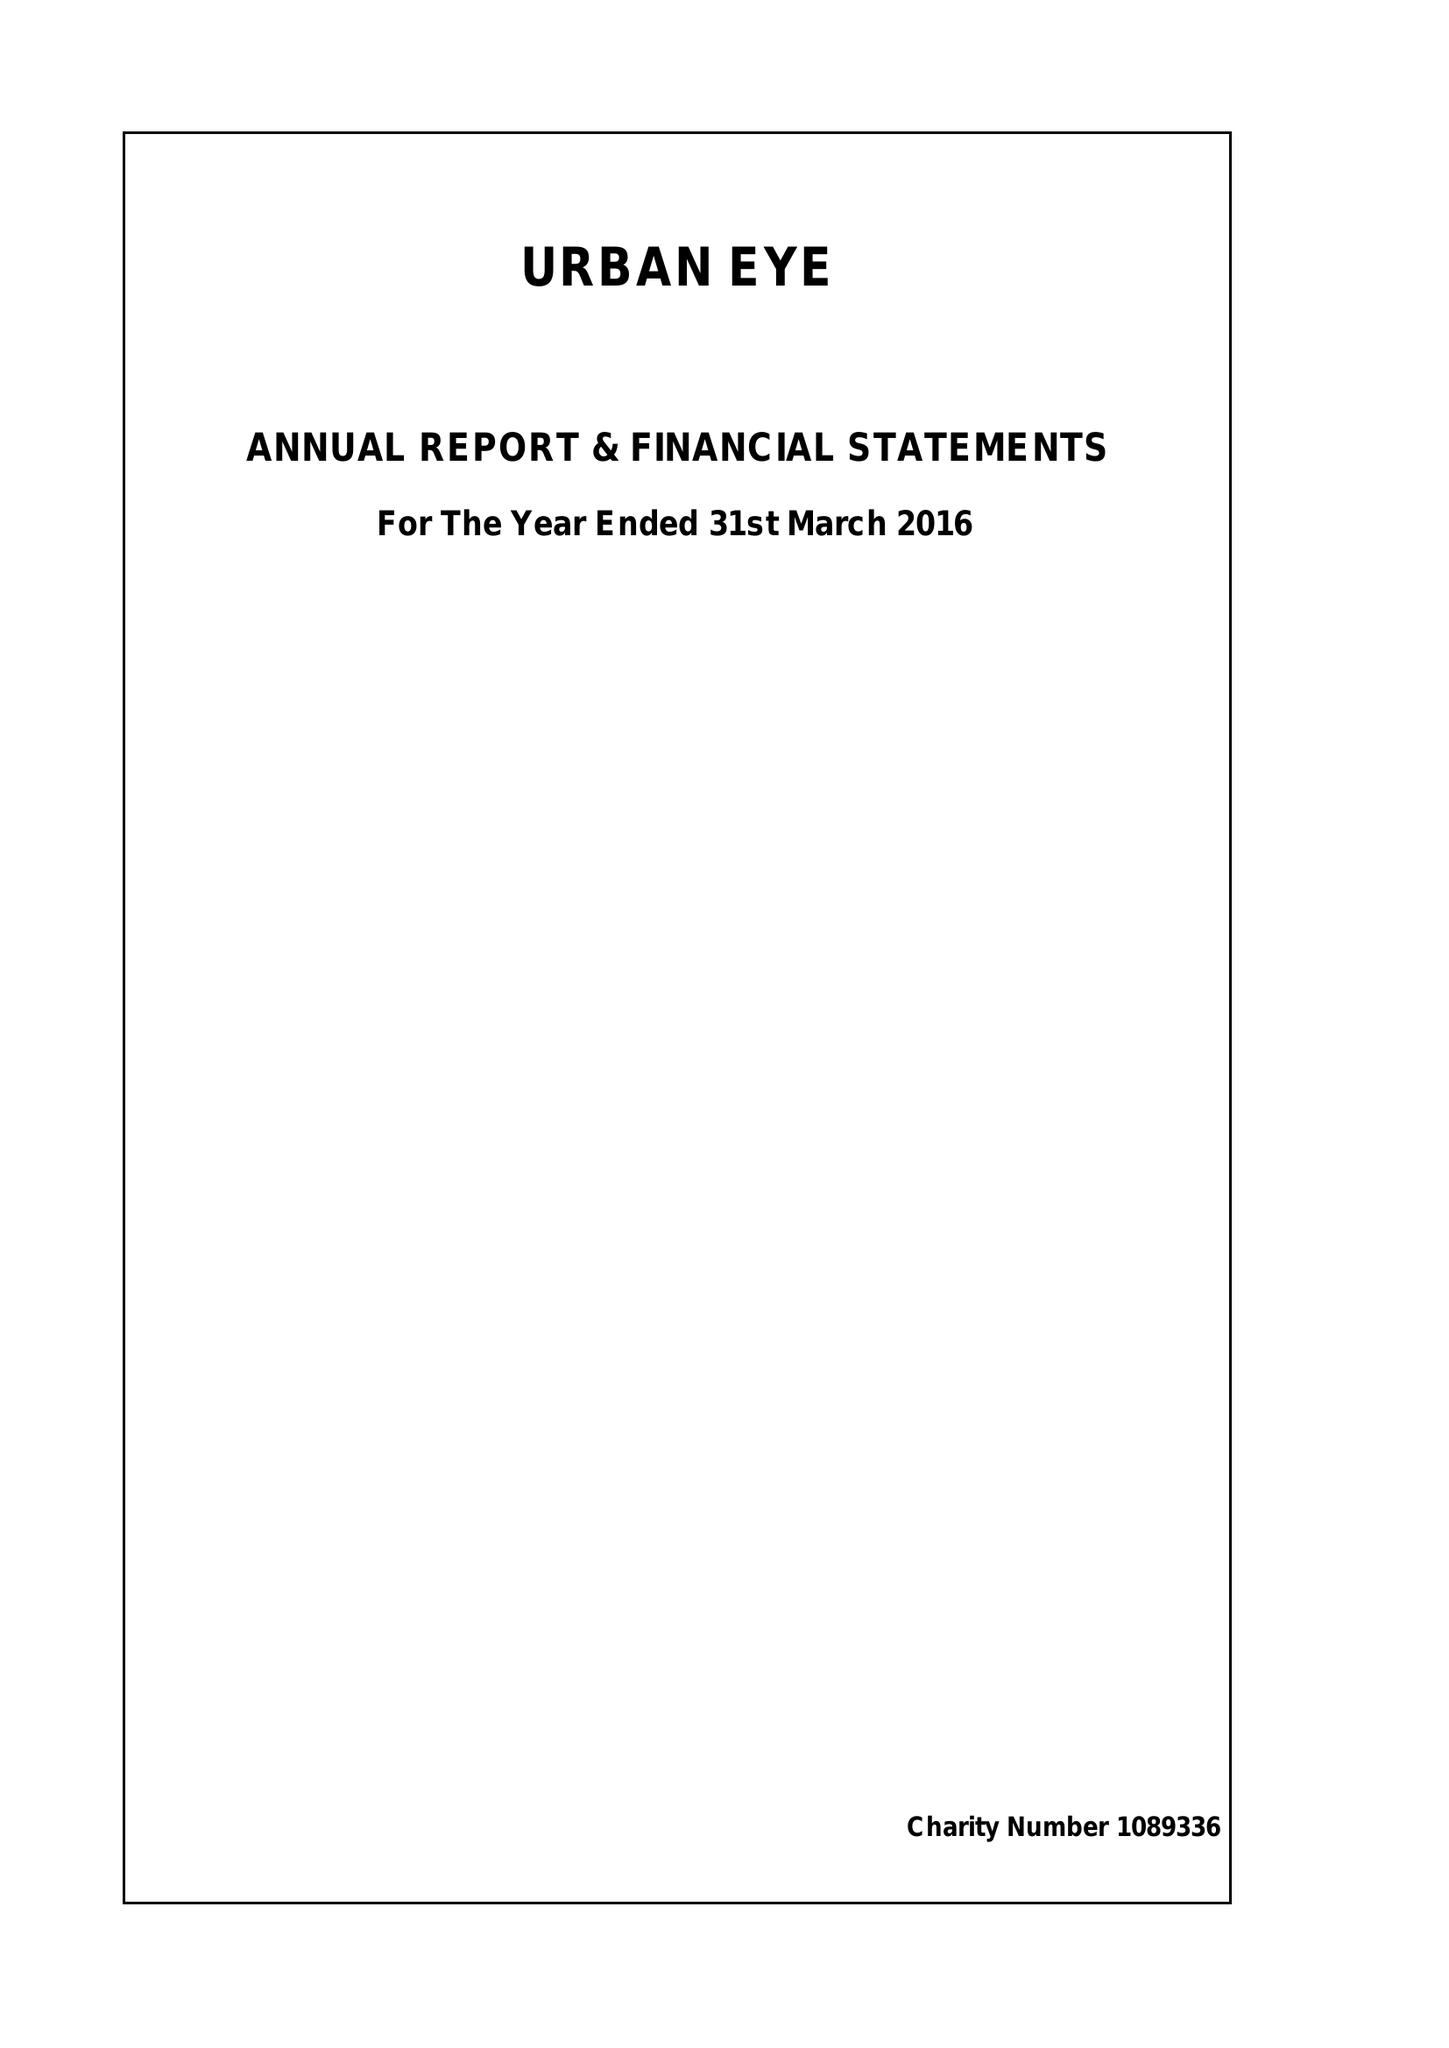What is the value for the spending_annually_in_british_pounds?
Answer the question using a single word or phrase. 42675.00 